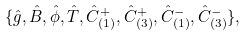Convert formula to latex. <formula><loc_0><loc_0><loc_500><loc_500>\{ \hat { g } , \hat { B } , \hat { \phi } , \hat { T } , \hat { C } _ { ( 1 ) } ^ { + } , \hat { C } _ { ( 3 ) } ^ { + } , \hat { C } _ { ( 1 ) } ^ { - } , \hat { C } _ { ( 3 ) } ^ { - } \} ,</formula> 